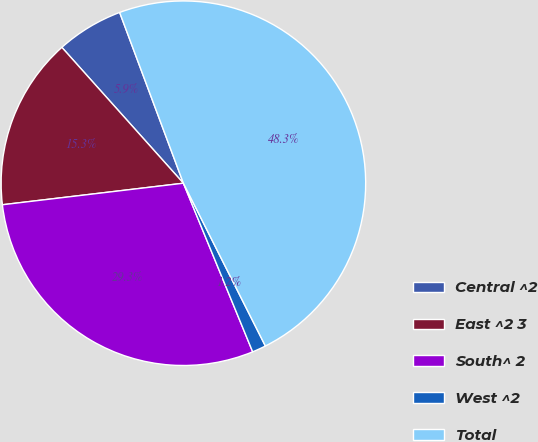Convert chart to OTSL. <chart><loc_0><loc_0><loc_500><loc_500><pie_chart><fcel>Central ^2<fcel>East ^2 3<fcel>South^ 2<fcel>West ^2<fcel>Total<nl><fcel>5.93%<fcel>15.27%<fcel>29.32%<fcel>1.22%<fcel>48.26%<nl></chart> 